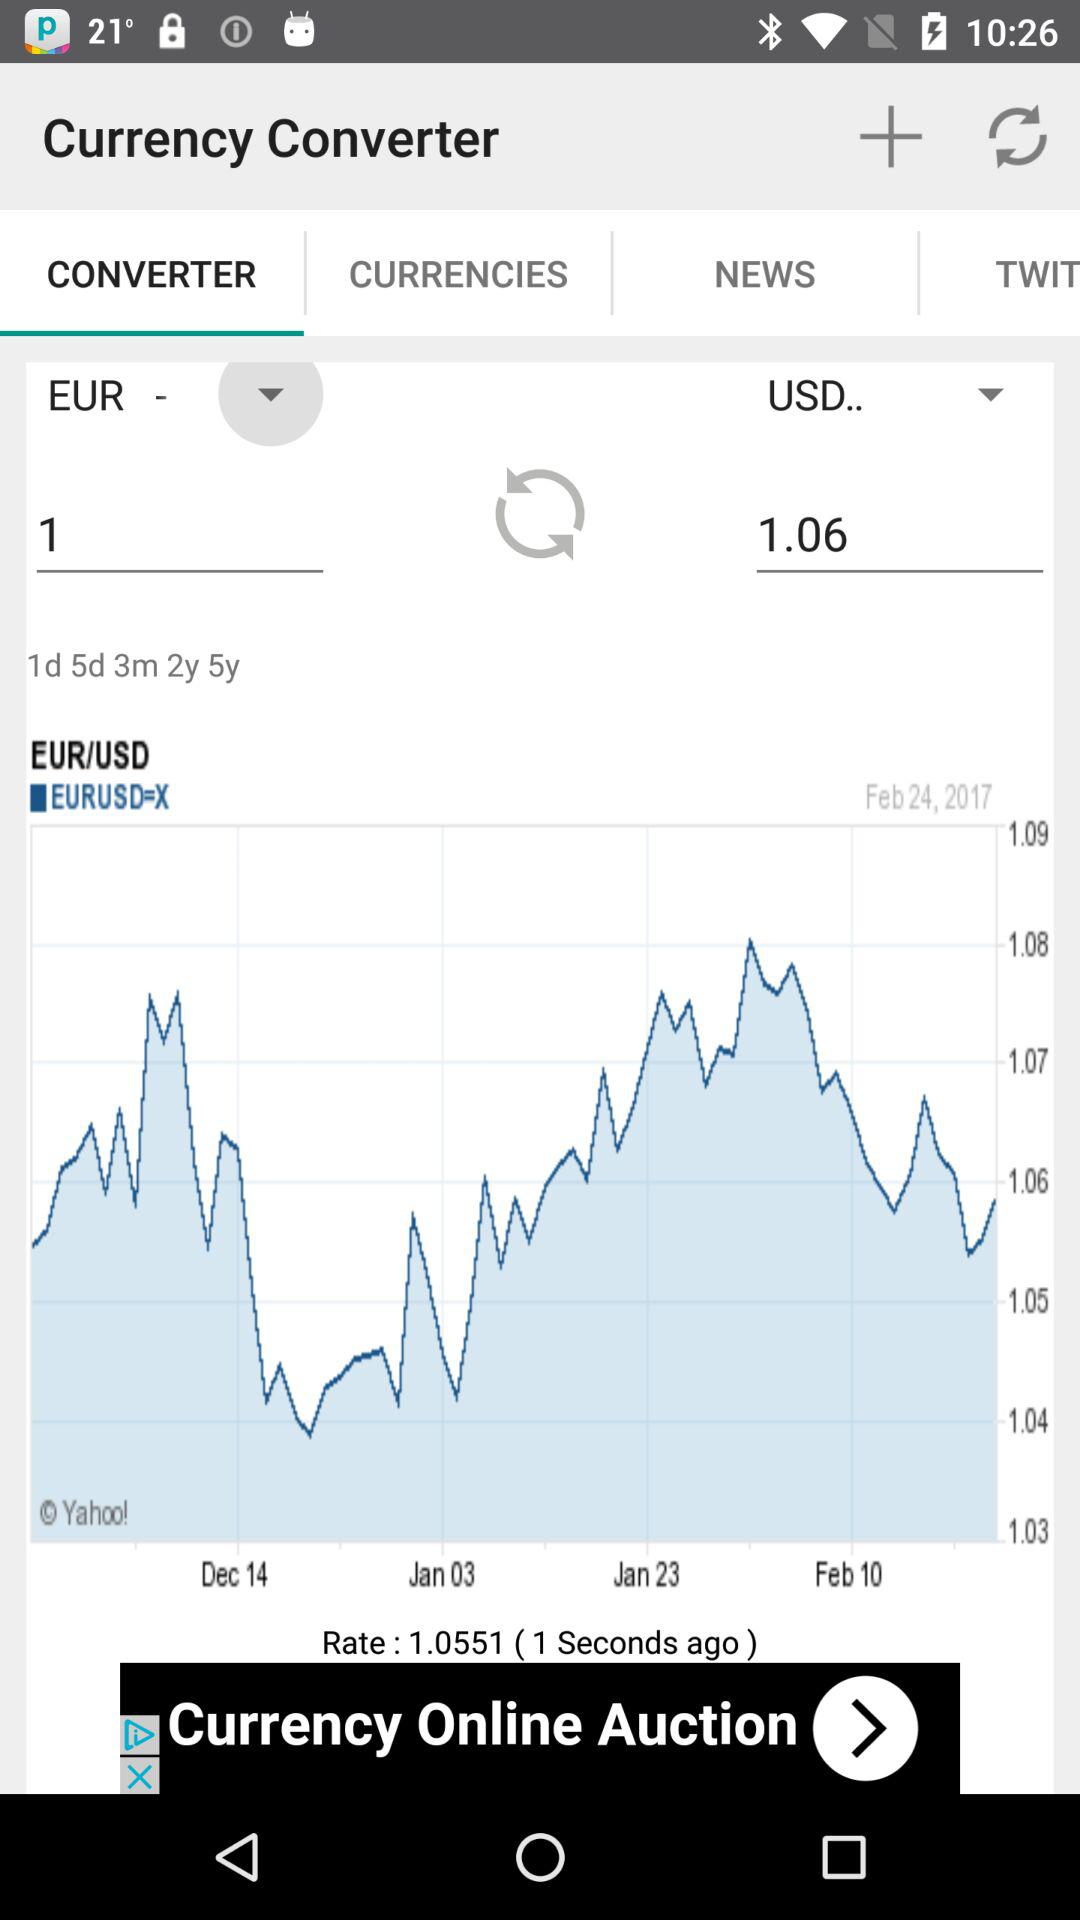What is the date? The dates are February 24, 2017, December 14, January 3, January 23 and February 10. 